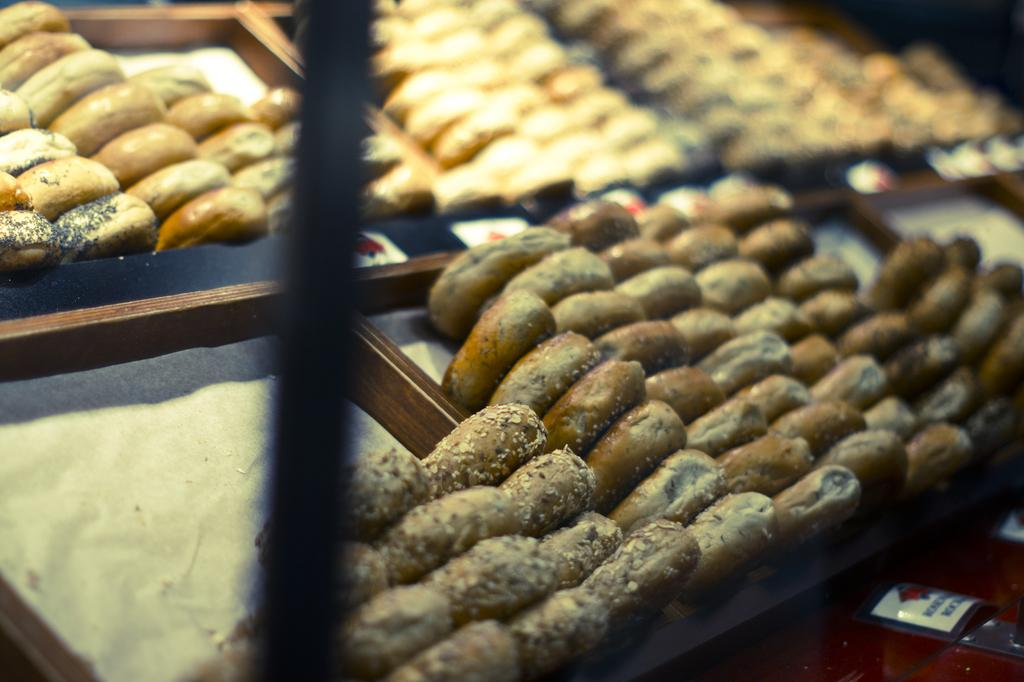What can be found in the trays in the image? There is food in the trays in the image. What type of drug is being distributed in the image? There is no drug present in the image; it features food in trays. What is the plot of the story unfolding in the image? There is no story or plot depicted in the image; it simply shows food in trays. 